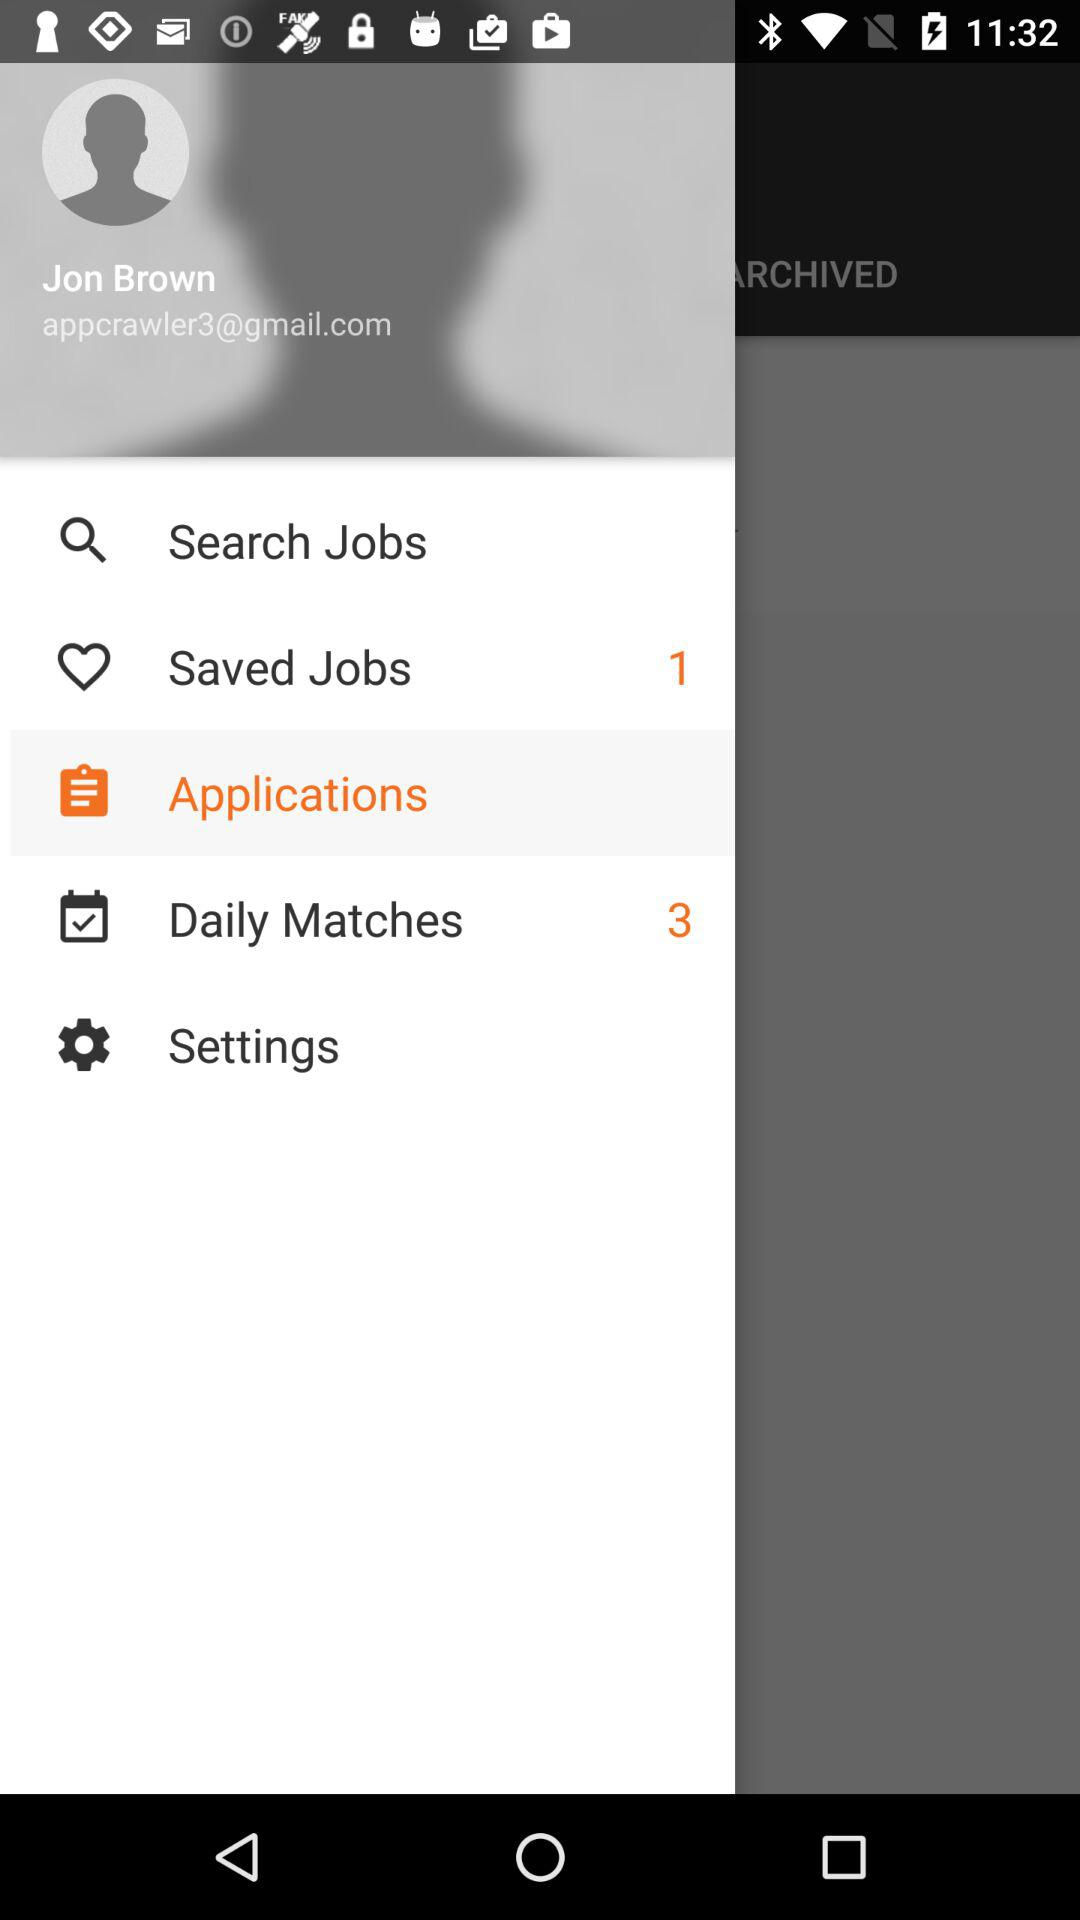What's the number of daily matches? The number of daily matches is 3. 